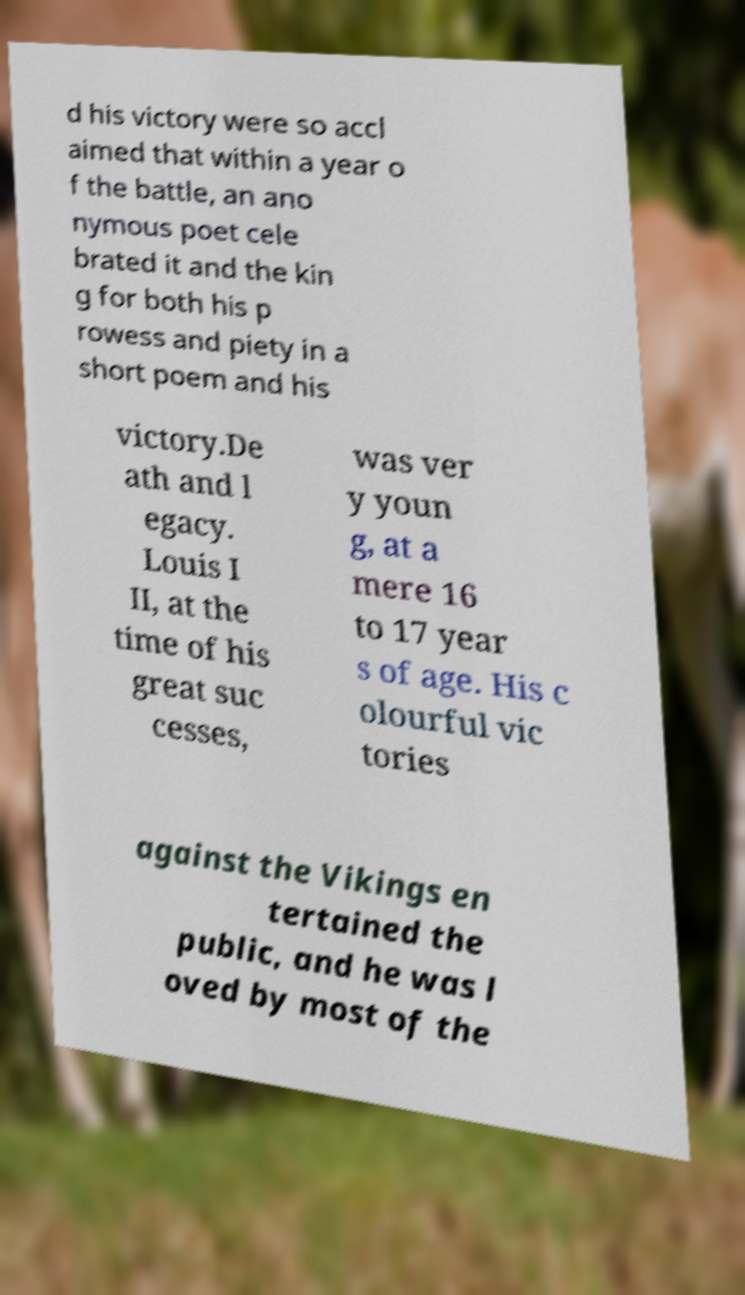Can you accurately transcribe the text from the provided image for me? d his victory were so accl aimed that within a year o f the battle, an ano nymous poet cele brated it and the kin g for both his p rowess and piety in a short poem and his victory.De ath and l egacy. Louis I II, at the time of his great suc cesses, was ver y youn g, at a mere 16 to 17 year s of age. His c olourful vic tories against the Vikings en tertained the public, and he was l oved by most of the 